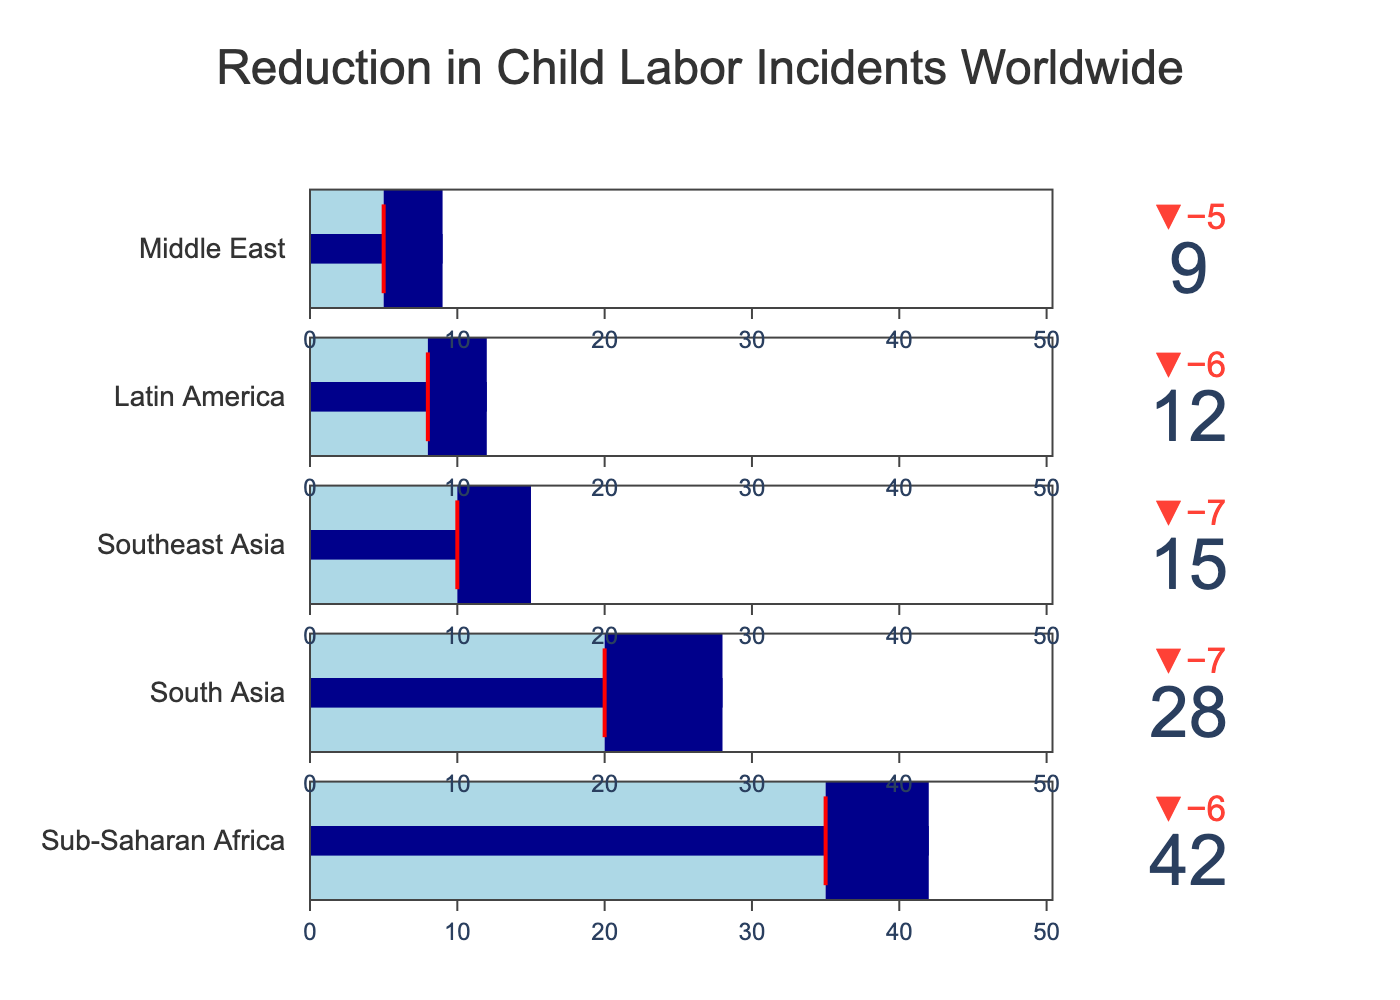What is the title of the figure? The title is usually located at the top of the figure and is used to describe the overall content.
Answer: Reduction in Child Labor Incidents Worldwide How many regions are displayed in the figure? By counting the number of indicators (or bullet charts), we can determine the number of regions.
Answer: 5 What is the target value for child labor reduction in South Asia? Locate the South Asia section and identify the target value marked by a red threshold line.
Answer: 20 Which region has the highest actual value of child labor incidents? Compare the actual values (indicated by the length of the dark blue bar) for all regions. The region with the longest bar has the highest value.
Answer: Sub-Saharan Africa Which region has made the greatest improvement compared to the previous year? The greatest improvement is indicated by the largest discrepancy between the previous year's value and the current actual value (delta). Calculate the difference for each region and find the largest one.
Answer: Sub-Saharan Africa Which region has an actual child labor incident value that meets or exceeds its target value? Compare the actual values with the target values for each region. If the actual value is greater than or equal to the target, it meets or exceeds the target.
Answer: None By how much did child labor incidents decrease in Latin America from the previous year? Subtract the actual value from the previous year's value for Latin America to find the decrease. 18 - 12 = 6
Answer: 6 Is Southeast Asia closer to its target compared to South Asia? Compare the distances between the actual values and the targets for both Southeast Asia and South Asia. Southeast Asia: 15 - 10 = 5, South Asia: 28 - 20 = 8
Answer: Yes Which region's actual value deviates most from its target? Calculate the deviation by subtracting the target value from the actual value for each region. The region with the highest deviation has the greatest difference.
Answer: South Asia 